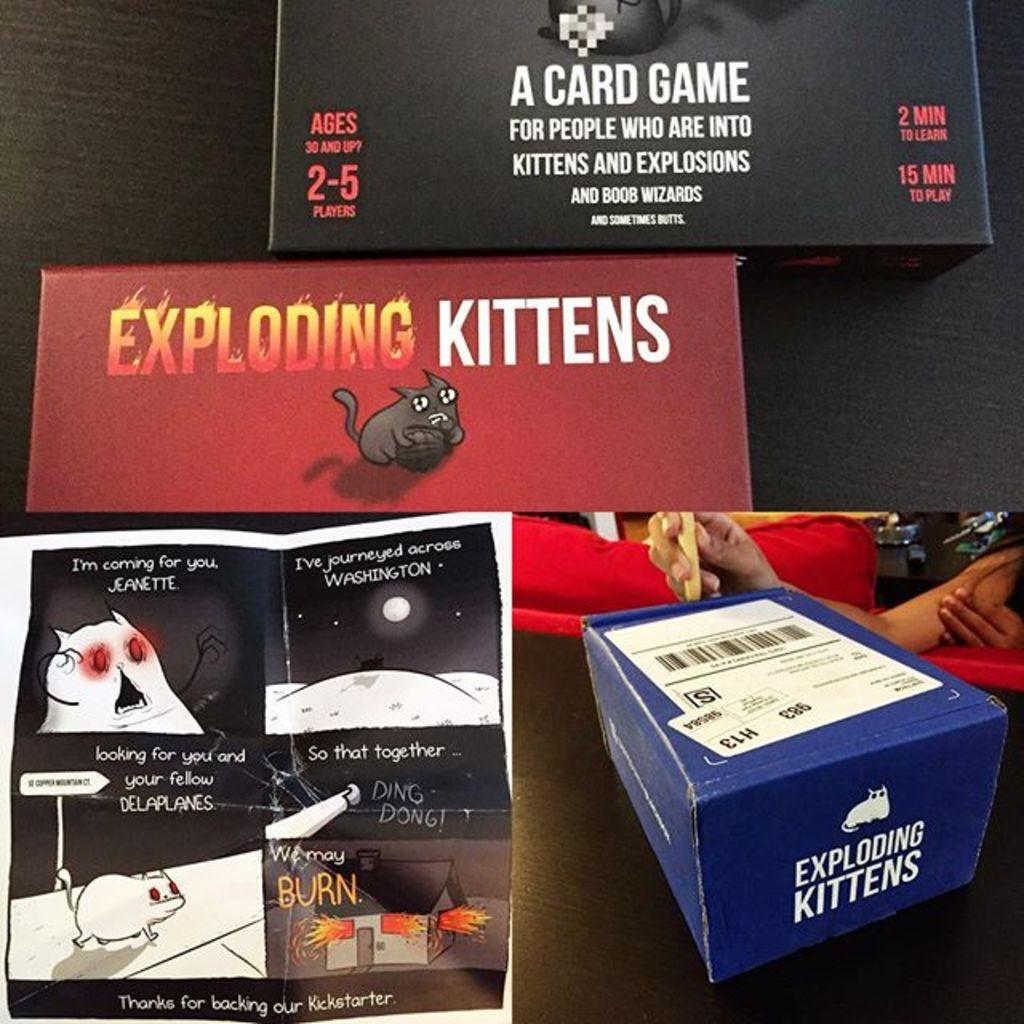<image>
Summarize the visual content of the image. A card game called "exploding kittens" seems to be humor based and aimed at adults. 